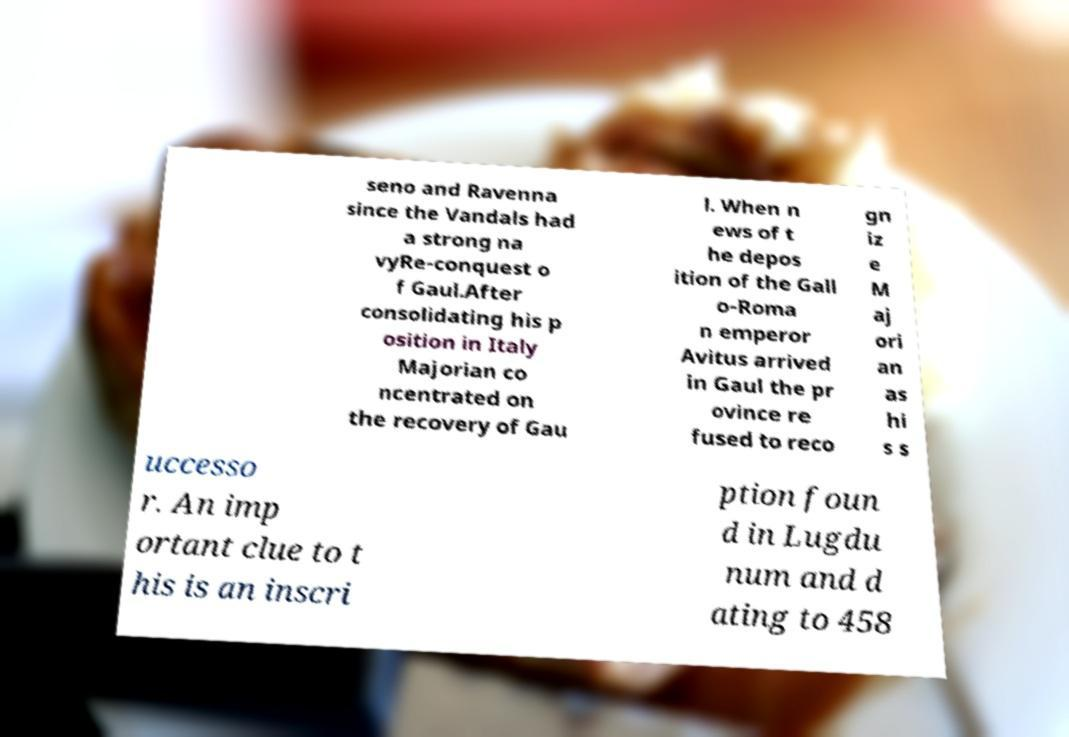There's text embedded in this image that I need extracted. Can you transcribe it verbatim? seno and Ravenna since the Vandals had a strong na vyRe-conquest o f Gaul.After consolidating his p osition in Italy Majorian co ncentrated on the recovery of Gau l. When n ews of t he depos ition of the Gall o-Roma n emperor Avitus arrived in Gaul the pr ovince re fused to reco gn iz e M aj ori an as hi s s uccesso r. An imp ortant clue to t his is an inscri ption foun d in Lugdu num and d ating to 458 